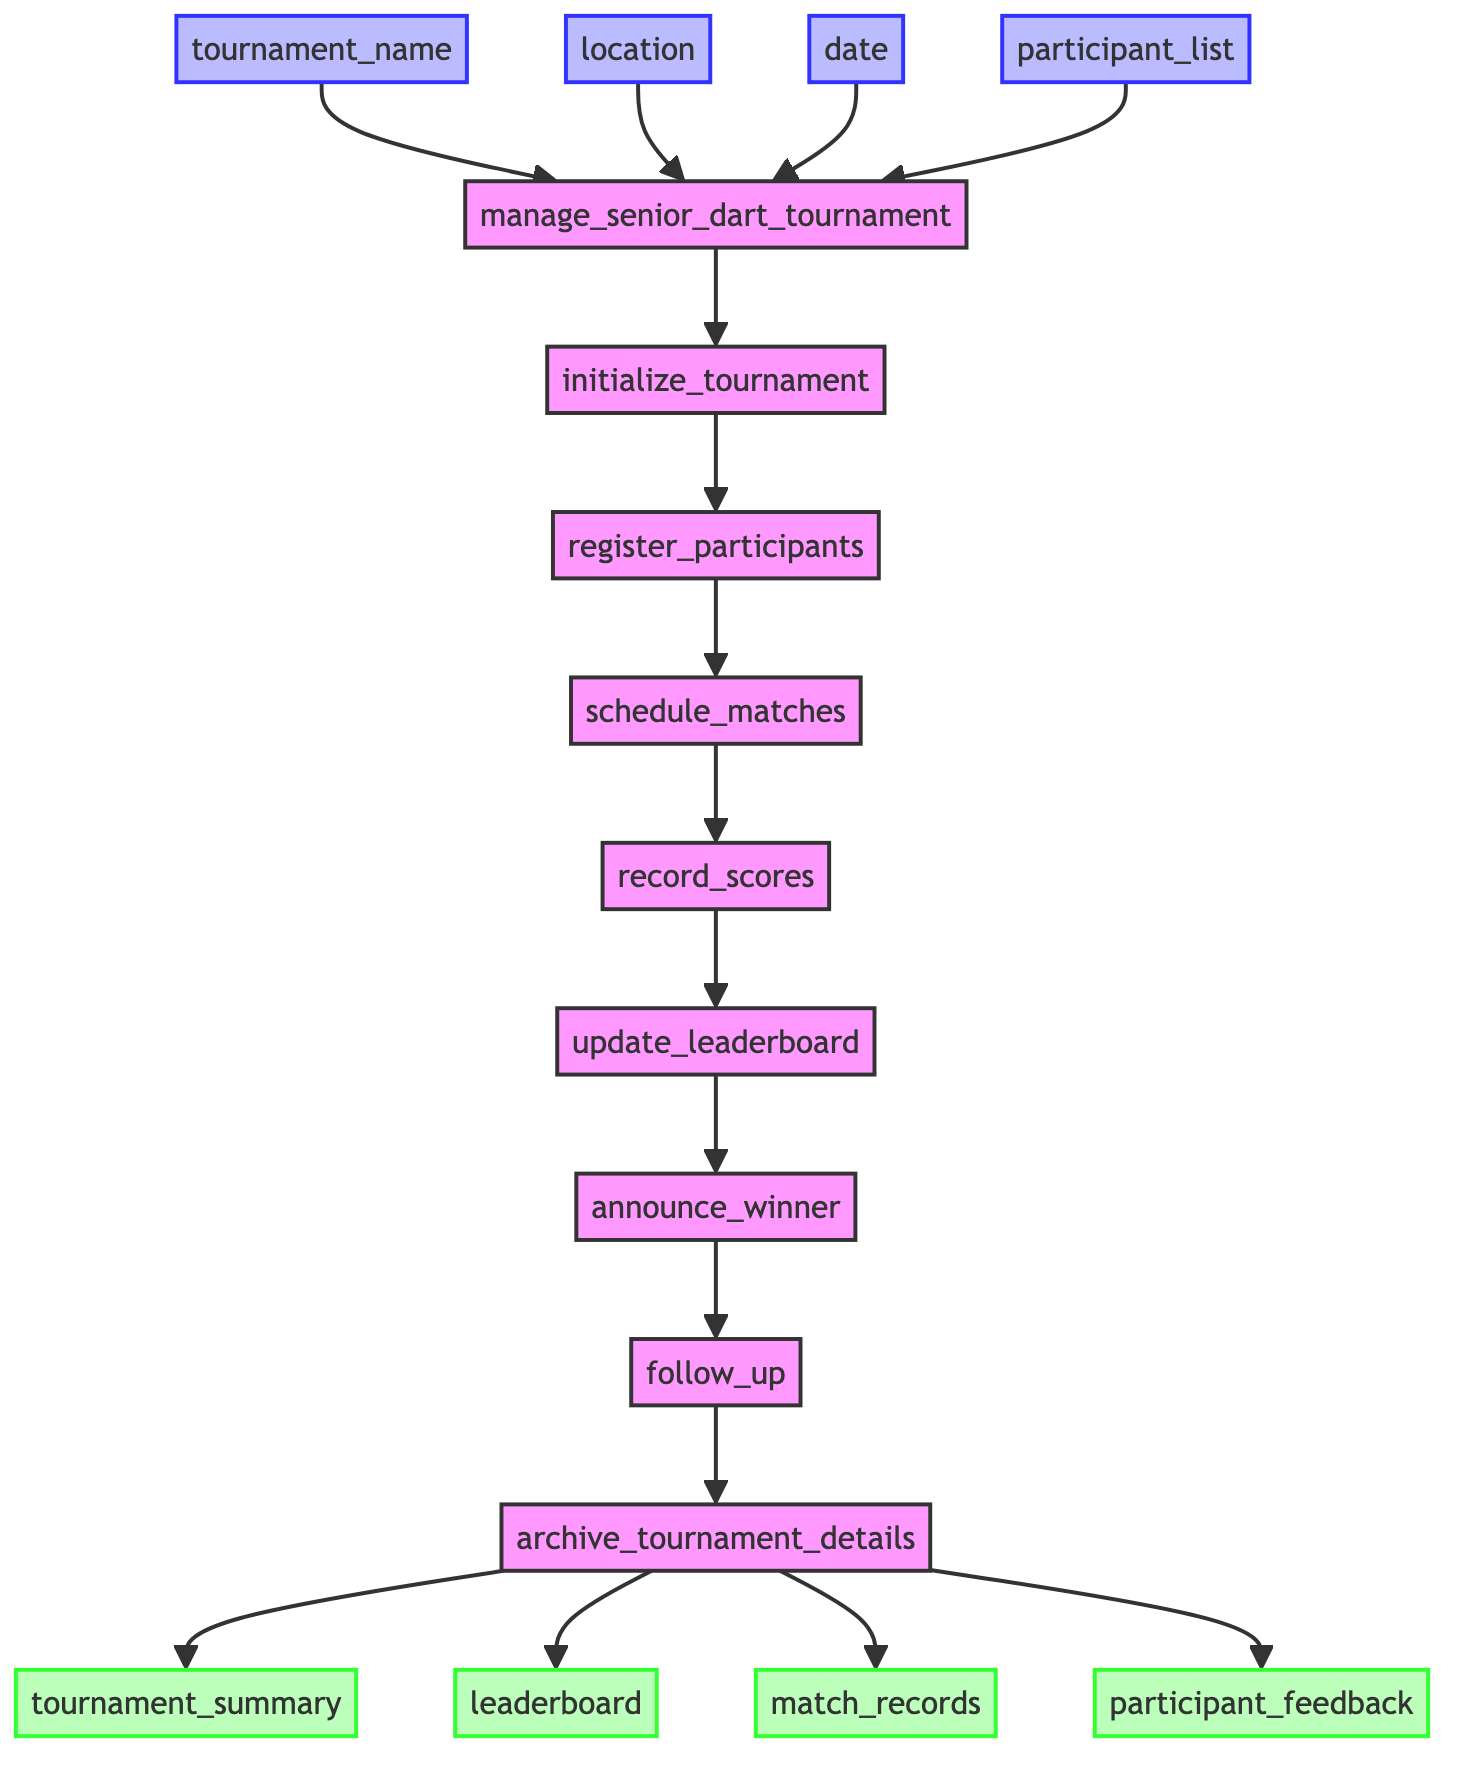What is the first step in the tournament management process? The first step in the flowchart is "initialize_tournament," which is the initial action taken after the function starts.
Answer: initialize_tournament How many outputs are there in this diagram? The diagram shows four outputs listed: tournament_summary, leaderboard, match_records, and participant_feedback. Counting these, we find there are four outputs.
Answer: four What step follows after "record_scores"? The next step after "record_scores" in the flowchart is "update_leaderboard." This indicates that the scoring leads directly into updating the standings based on those scores.
Answer: update_leaderboard What is the purpose of the "follow_up" step? The "follow_up" step is meant to send post-tournament feedback forms to participants and update any records, indicating its role in gathering insights after the tournament concludes.
Answer: Send feedback forms How many steps are there in total within the function? The diagram lists eight distinct steps in the process of managing the tournament, from initialization to archiving details. Therefore, the total number of steps is eight.
Answer: eight Which input is needed to initialize the tournament? The inputs required for the "manage_senior_dart_tournament" function include tournament_name, location, date, and participant_list. Each is crucial for the initialization process.
Answer: tournament_name, location, date, participant_list What does the last step of the function accomplish? The last step, "archive_tournament_details," is responsible for archiving all details of the tournament, ensuring they are stored for future reference. This is crucial for maintaining a history of events that have occurred.
Answer: Archive details What is recorded right after matches are played? After matches are played, the "record_scores" step is executed, where the scores from those matches are recorded, marking an essential part of updating the tournament status.
Answer: record_scores What action is taken after announcing the winner? After the "announce_winner" step, the next action in the flowchart is to "follow_up," illustrating the process of engaging with all participants after the conclusion of the tournament.
Answer: follow_up 